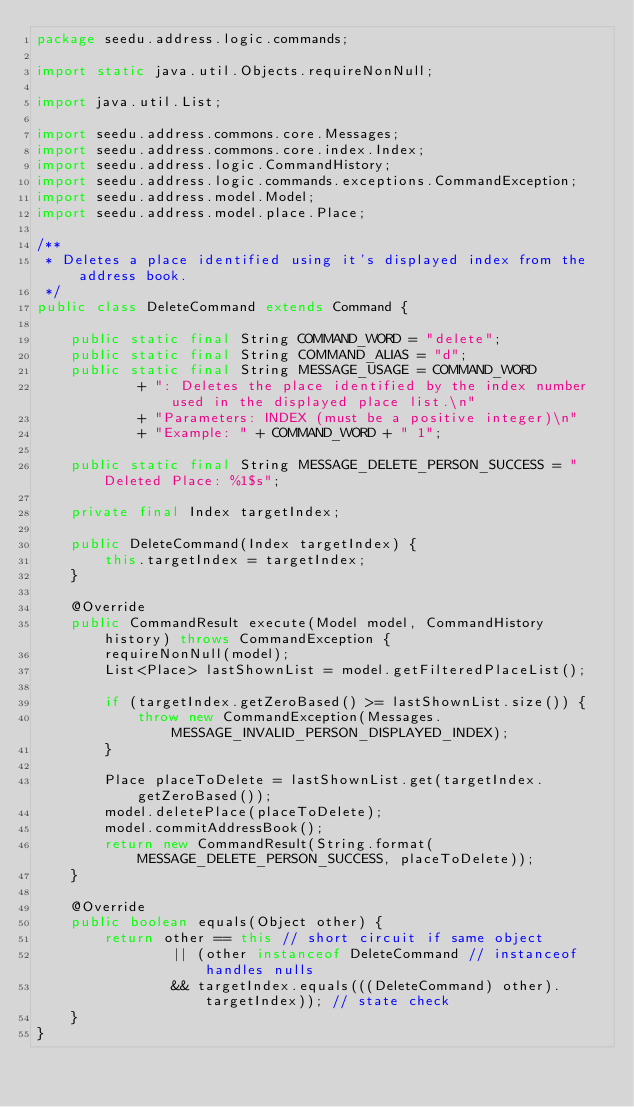<code> <loc_0><loc_0><loc_500><loc_500><_Java_>package seedu.address.logic.commands;

import static java.util.Objects.requireNonNull;

import java.util.List;

import seedu.address.commons.core.Messages;
import seedu.address.commons.core.index.Index;
import seedu.address.logic.CommandHistory;
import seedu.address.logic.commands.exceptions.CommandException;
import seedu.address.model.Model;
import seedu.address.model.place.Place;

/**
 * Deletes a place identified using it's displayed index from the address book.
 */
public class DeleteCommand extends Command {

    public static final String COMMAND_WORD = "delete";
    public static final String COMMAND_ALIAS = "d";
    public static final String MESSAGE_USAGE = COMMAND_WORD
            + ": Deletes the place identified by the index number used in the displayed place list.\n"
            + "Parameters: INDEX (must be a positive integer)\n"
            + "Example: " + COMMAND_WORD + " 1";

    public static final String MESSAGE_DELETE_PERSON_SUCCESS = "Deleted Place: %1$s";

    private final Index targetIndex;

    public DeleteCommand(Index targetIndex) {
        this.targetIndex = targetIndex;
    }

    @Override
    public CommandResult execute(Model model, CommandHistory history) throws CommandException {
        requireNonNull(model);
        List<Place> lastShownList = model.getFilteredPlaceList();

        if (targetIndex.getZeroBased() >= lastShownList.size()) {
            throw new CommandException(Messages.MESSAGE_INVALID_PERSON_DISPLAYED_INDEX);
        }

        Place placeToDelete = lastShownList.get(targetIndex.getZeroBased());
        model.deletePlace(placeToDelete);
        model.commitAddressBook();
        return new CommandResult(String.format(MESSAGE_DELETE_PERSON_SUCCESS, placeToDelete));
    }

    @Override
    public boolean equals(Object other) {
        return other == this // short circuit if same object
                || (other instanceof DeleteCommand // instanceof handles nulls
                && targetIndex.equals(((DeleteCommand) other).targetIndex)); // state check
    }
}
</code> 